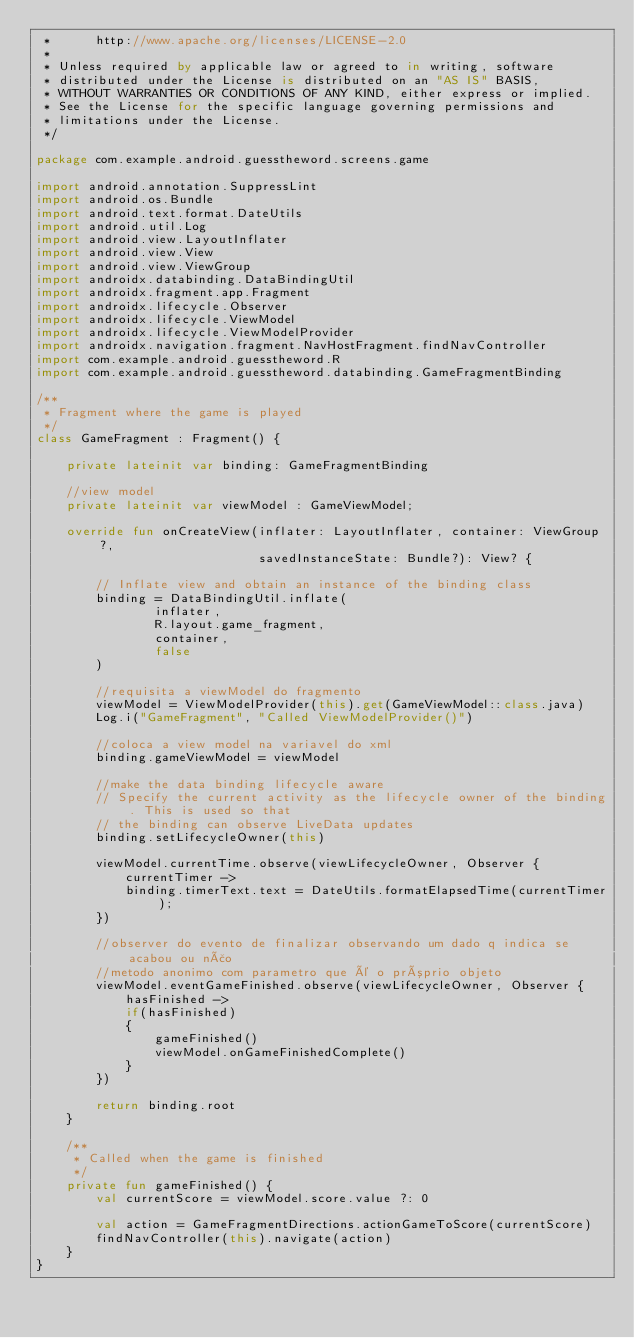<code> <loc_0><loc_0><loc_500><loc_500><_Kotlin_> *      http://www.apache.org/licenses/LICENSE-2.0
 *
 * Unless required by applicable law or agreed to in writing, software
 * distributed under the License is distributed on an "AS IS" BASIS,
 * WITHOUT WARRANTIES OR CONDITIONS OF ANY KIND, either express or implied.
 * See the License for the specific language governing permissions and
 * limitations under the License.
 */

package com.example.android.guesstheword.screens.game

import android.annotation.SuppressLint
import android.os.Bundle
import android.text.format.DateUtils
import android.util.Log
import android.view.LayoutInflater
import android.view.View
import android.view.ViewGroup
import androidx.databinding.DataBindingUtil
import androidx.fragment.app.Fragment
import androidx.lifecycle.Observer
import androidx.lifecycle.ViewModel
import androidx.lifecycle.ViewModelProvider
import androidx.navigation.fragment.NavHostFragment.findNavController
import com.example.android.guesstheword.R
import com.example.android.guesstheword.databinding.GameFragmentBinding

/**
 * Fragment where the game is played
 */
class GameFragment : Fragment() {

    private lateinit var binding: GameFragmentBinding

    //view model
    private lateinit var viewModel : GameViewModel;

    override fun onCreateView(inflater: LayoutInflater, container: ViewGroup?,
                              savedInstanceState: Bundle?): View? {

        // Inflate view and obtain an instance of the binding class
        binding = DataBindingUtil.inflate(
                inflater,
                R.layout.game_fragment,
                container,
                false
        )

        //requisita a viewModel do fragmento
        viewModel = ViewModelProvider(this).get(GameViewModel::class.java)
        Log.i("GameFragment", "Called ViewModelProvider()")

        //coloca a view model na variavel do xml
        binding.gameViewModel = viewModel

        //make the data binding lifecycle aware
        // Specify the current activity as the lifecycle owner of the binding. This is used so that
        // the binding can observe LiveData updates
        binding.setLifecycleOwner(this)

        viewModel.currentTime.observe(viewLifecycleOwner, Observer {
            currentTimer ->
            binding.timerText.text = DateUtils.formatElapsedTime(currentTimer);
        })

        //observer do evento de finalizar observando um dado q indica se acabou ou não
        //metodo anonimo com parametro que é o próprio objeto
        viewModel.eventGameFinished.observe(viewLifecycleOwner, Observer {
            hasFinished ->
            if(hasFinished)
            {
                gameFinished()
                viewModel.onGameFinishedComplete()
            }
        })

        return binding.root
    }

    /**
     * Called when the game is finished
     */
    private fun gameFinished() {
        val currentScore = viewModel.score.value ?: 0

        val action = GameFragmentDirections.actionGameToScore(currentScore)
        findNavController(this).navigate(action)
    }
}
</code> 